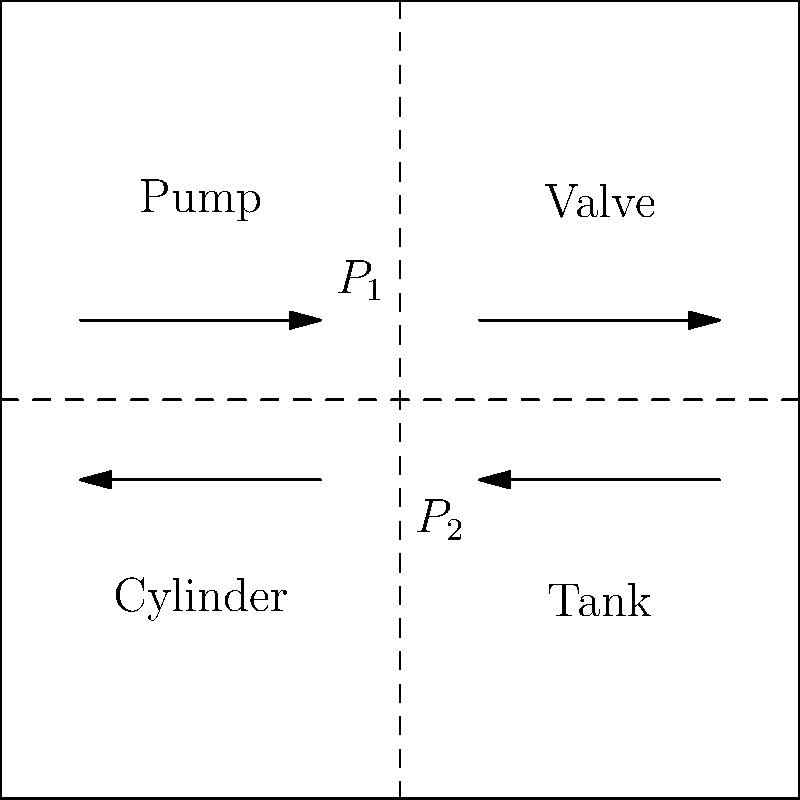In the hydraulic system diagram for a snowplow, the pressure at point $P_1$ is 2000 psi, and the pressure at point $P_2$ is 500 psi. What is the pressure drop across the valve, and how might this affect the snowplow's operation? To solve this problem, we need to follow these steps:

1. Identify the pressure points:
   $P_1$ is located before the valve (high-pressure side)
   $P_2$ is located after the valve (low-pressure side)

2. Calculate the pressure drop:
   Pressure drop = $P_1 - P_2$
   Pressure drop = 2000 psi - 500 psi = 1500 psi

3. Analyze the effect on snowplow operation:
   a) The significant pressure drop (1500 psi) indicates that the valve is restricting flow considerably.
   b) This restriction could be intentional for controlling the snowplow's hydraulic functions, such as blade movement or angle adjustment.
   c) However, if this drop is larger than designed, it might indicate:
      - Valve wear or damage
      - Contamination in the hydraulic fluid
      - Incorrect valve adjustment

4. Potential impacts on snowplow operation:
   a) Reduced hydraulic power available for blade movement
   b) Slower response time for snowplow controls
   c) Increased heat generation in the hydraulic system
   d) Possible damage to other components due to increased backpressure

5. Recommendation:
   If this pressure drop is not within the manufacturer's specifications, it would be advisable to inspect the valve, check for contamination, and potentially replace or adjust the valve to ensure optimal snowplow performance and prevent system damage.
Answer: 1500 psi pressure drop; may reduce hydraulic power and responsiveness. 